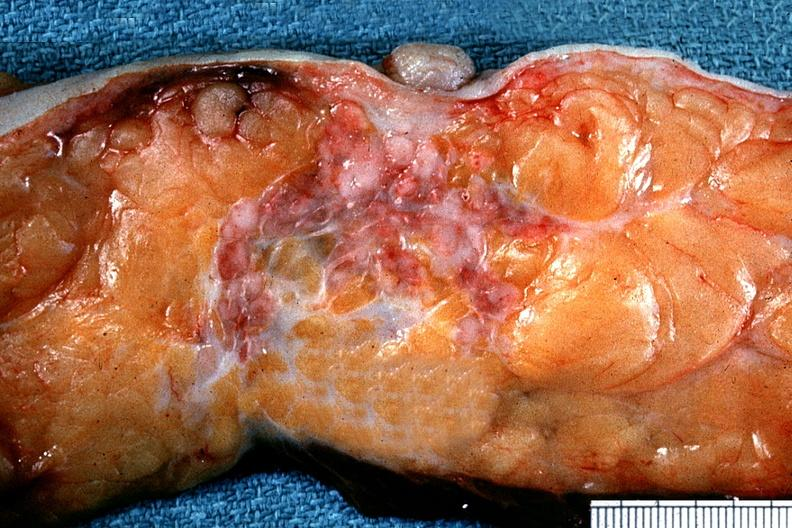does this image show excellent example of carcinoma below nipple in cross section?
Answer the question using a single word or phrase. Yes 